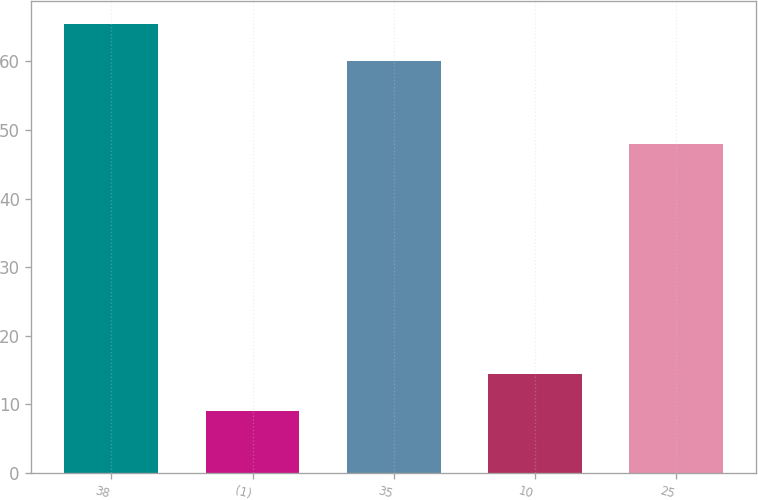Convert chart. <chart><loc_0><loc_0><loc_500><loc_500><bar_chart><fcel>38<fcel>(1)<fcel>35<fcel>10<fcel>25<nl><fcel>65.5<fcel>9<fcel>60<fcel>14.5<fcel>48<nl></chart> 